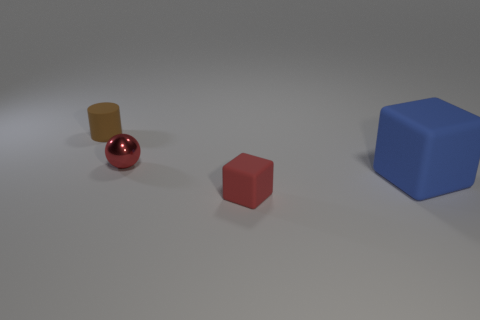How do the textures of the objects differ? The objects exhibit a variety of textures: the small sphere has a reflective, shiny surface, indicative of a smooth and polished material. The cube appears to have a matte finish, suggesting a more diffused light reflection. The cylinder, while also having a matte finish, presents a slightly different texture, perhaps more akin to brushed metal or a roughened surface. 